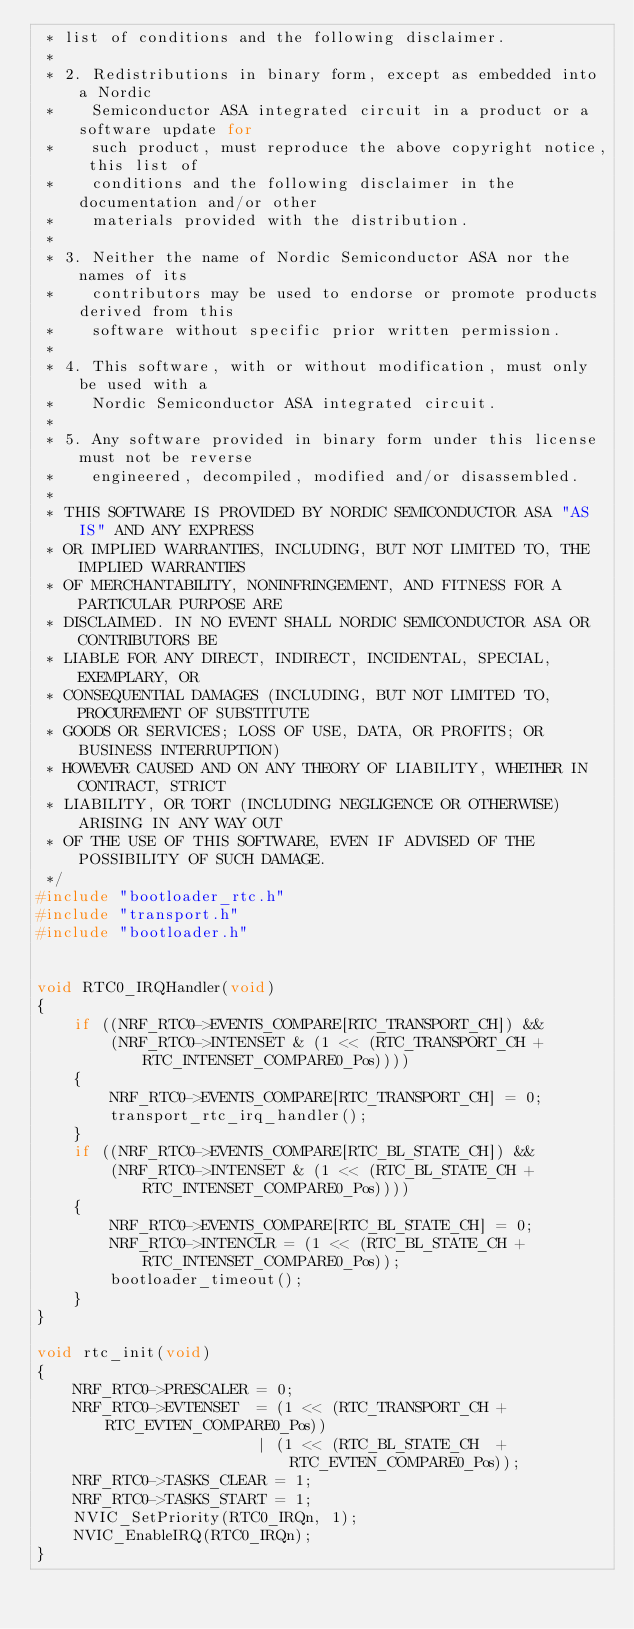<code> <loc_0><loc_0><loc_500><loc_500><_C_> * list of conditions and the following disclaimer.
 *
 * 2. Redistributions in binary form, except as embedded into a Nordic
 *    Semiconductor ASA integrated circuit in a product or a software update for
 *    such product, must reproduce the above copyright notice, this list of
 *    conditions and the following disclaimer in the documentation and/or other
 *    materials provided with the distribution.
 *
 * 3. Neither the name of Nordic Semiconductor ASA nor the names of its
 *    contributors may be used to endorse or promote products derived from this
 *    software without specific prior written permission.
 *
 * 4. This software, with or without modification, must only be used with a
 *    Nordic Semiconductor ASA integrated circuit.
 *
 * 5. Any software provided in binary form under this license must not be reverse
 *    engineered, decompiled, modified and/or disassembled.
 *
 * THIS SOFTWARE IS PROVIDED BY NORDIC SEMICONDUCTOR ASA "AS IS" AND ANY EXPRESS
 * OR IMPLIED WARRANTIES, INCLUDING, BUT NOT LIMITED TO, THE IMPLIED WARRANTIES
 * OF MERCHANTABILITY, NONINFRINGEMENT, AND FITNESS FOR A PARTICULAR PURPOSE ARE
 * DISCLAIMED. IN NO EVENT SHALL NORDIC SEMICONDUCTOR ASA OR CONTRIBUTORS BE
 * LIABLE FOR ANY DIRECT, INDIRECT, INCIDENTAL, SPECIAL, EXEMPLARY, OR
 * CONSEQUENTIAL DAMAGES (INCLUDING, BUT NOT LIMITED TO, PROCUREMENT OF SUBSTITUTE
 * GOODS OR SERVICES; LOSS OF USE, DATA, OR PROFITS; OR BUSINESS INTERRUPTION)
 * HOWEVER CAUSED AND ON ANY THEORY OF LIABILITY, WHETHER IN CONTRACT, STRICT
 * LIABILITY, OR TORT (INCLUDING NEGLIGENCE OR OTHERWISE) ARISING IN ANY WAY OUT
 * OF THE USE OF THIS SOFTWARE, EVEN IF ADVISED OF THE POSSIBILITY OF SUCH DAMAGE.
 */
#include "bootloader_rtc.h"
#include "transport.h"
#include "bootloader.h"


void RTC0_IRQHandler(void)
{
    if ((NRF_RTC0->EVENTS_COMPARE[RTC_TRANSPORT_CH]) &&
        (NRF_RTC0->INTENSET & (1 << (RTC_TRANSPORT_CH + RTC_INTENSET_COMPARE0_Pos))))
    {
        NRF_RTC0->EVENTS_COMPARE[RTC_TRANSPORT_CH] = 0;
        transport_rtc_irq_handler();
    }
    if ((NRF_RTC0->EVENTS_COMPARE[RTC_BL_STATE_CH]) &&
        (NRF_RTC0->INTENSET & (1 << (RTC_BL_STATE_CH + RTC_INTENSET_COMPARE0_Pos))))
    {
        NRF_RTC0->EVENTS_COMPARE[RTC_BL_STATE_CH] = 0;
        NRF_RTC0->INTENCLR = (1 << (RTC_BL_STATE_CH + RTC_INTENSET_COMPARE0_Pos));
        bootloader_timeout();
    }
}

void rtc_init(void)
{
    NRF_RTC0->PRESCALER = 0;
    NRF_RTC0->EVTENSET  = (1 << (RTC_TRANSPORT_CH + RTC_EVTEN_COMPARE0_Pos))
                        | (1 << (RTC_BL_STATE_CH  + RTC_EVTEN_COMPARE0_Pos));
    NRF_RTC0->TASKS_CLEAR = 1;
    NRF_RTC0->TASKS_START = 1;
    NVIC_SetPriority(RTC0_IRQn, 1);
    NVIC_EnableIRQ(RTC0_IRQn);
}
</code> 